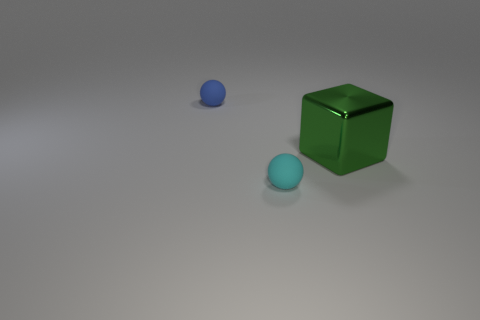Subtract all yellow cubes. Subtract all blue balls. How many cubes are left? 1 Add 2 matte things. How many objects exist? 5 Subtract all balls. How many objects are left? 1 Add 2 big green metallic blocks. How many big green metallic blocks are left? 3 Add 2 tiny cyan matte things. How many tiny cyan matte things exist? 3 Subtract 0 yellow balls. How many objects are left? 3 Subtract all green metallic blocks. Subtract all tiny objects. How many objects are left? 0 